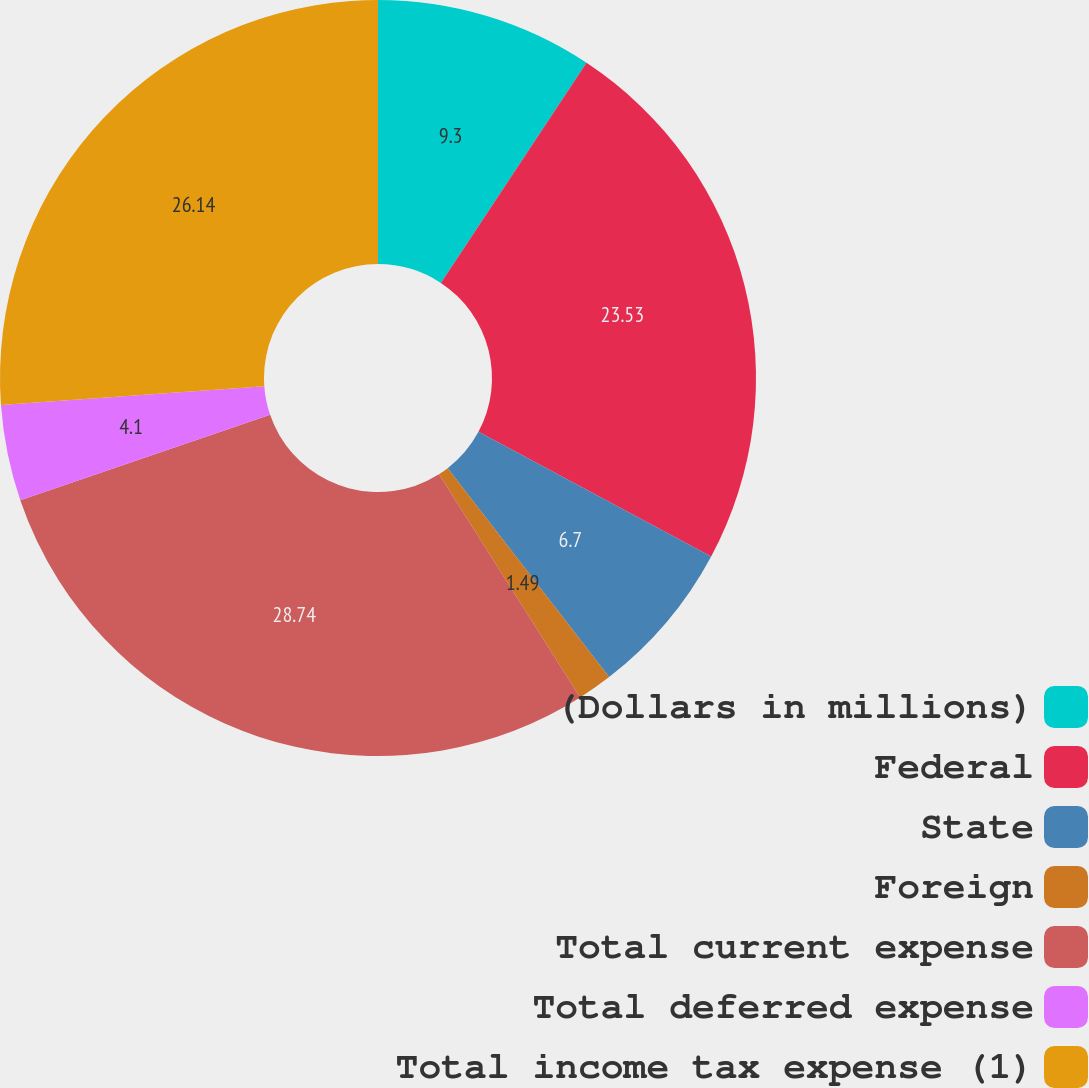Convert chart to OTSL. <chart><loc_0><loc_0><loc_500><loc_500><pie_chart><fcel>(Dollars in millions)<fcel>Federal<fcel>State<fcel>Foreign<fcel>Total current expense<fcel>Total deferred expense<fcel>Total income tax expense (1)<nl><fcel>9.3%<fcel>23.53%<fcel>6.7%<fcel>1.49%<fcel>28.74%<fcel>4.1%<fcel>26.14%<nl></chart> 